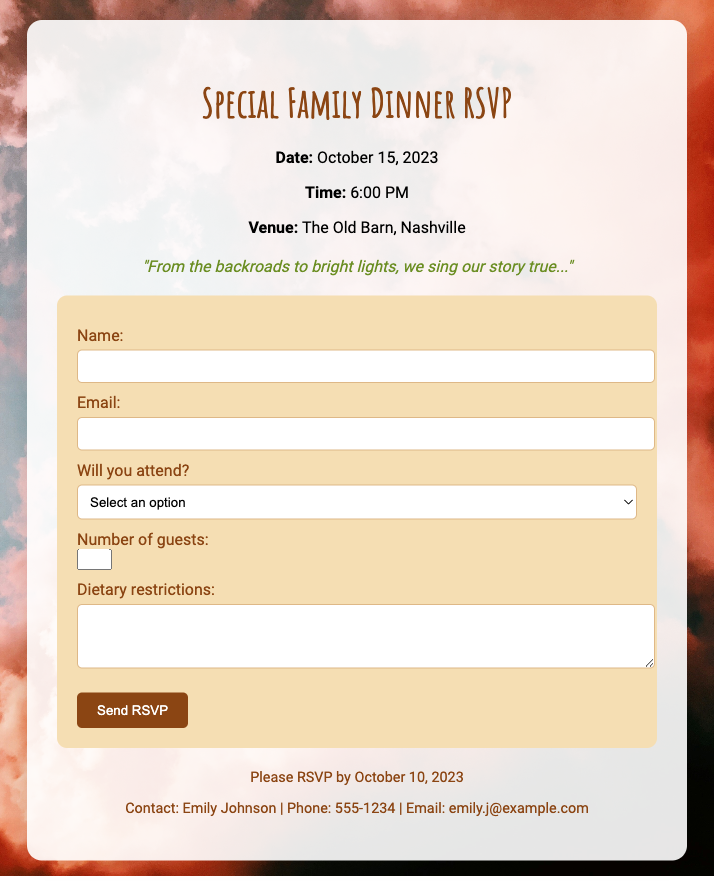What is the date of the dinner? The date of the dinner is explicitly stated in the document as October 15, 2023.
Answer: October 15, 2023 What time does the dinner start? The starting time for the dinner is provided in the event details section as 6:00 PM.
Answer: 6:00 PM Where will the dinner take place? The venue for the dinner is mentioned as The Old Barn, Nashville.
Answer: The Old Barn, Nashville What is the main theme of the dinner? The document mentions a rustic country theme for the family dinner.
Answer: Rustic country theme What is the RSVP deadline? The last date to send in the RSVP is noted as October 10, 2023.
Answer: October 10, 2023 Who should be contacted for more information? The document provides contact details for Emily Johnson for further inquiries.
Answer: Emily Johnson How many guests can be added in the RSVP? The input field for guests allows a maximum of 5 individuals to be added.
Answer: 5 What kind of song lyrics are featured on the card? The card includes personalized song lyrics that reflect the theme, specifically mentioning "From the backroads to bright lights, we sing our story true...".
Answer: "From the backroads to bright lights, we sing our story true..." Will attendees select their meal preferences? Attendees can mention their dietary restrictions through a dedicated textarea in the RSVP form.
Answer: Yes 